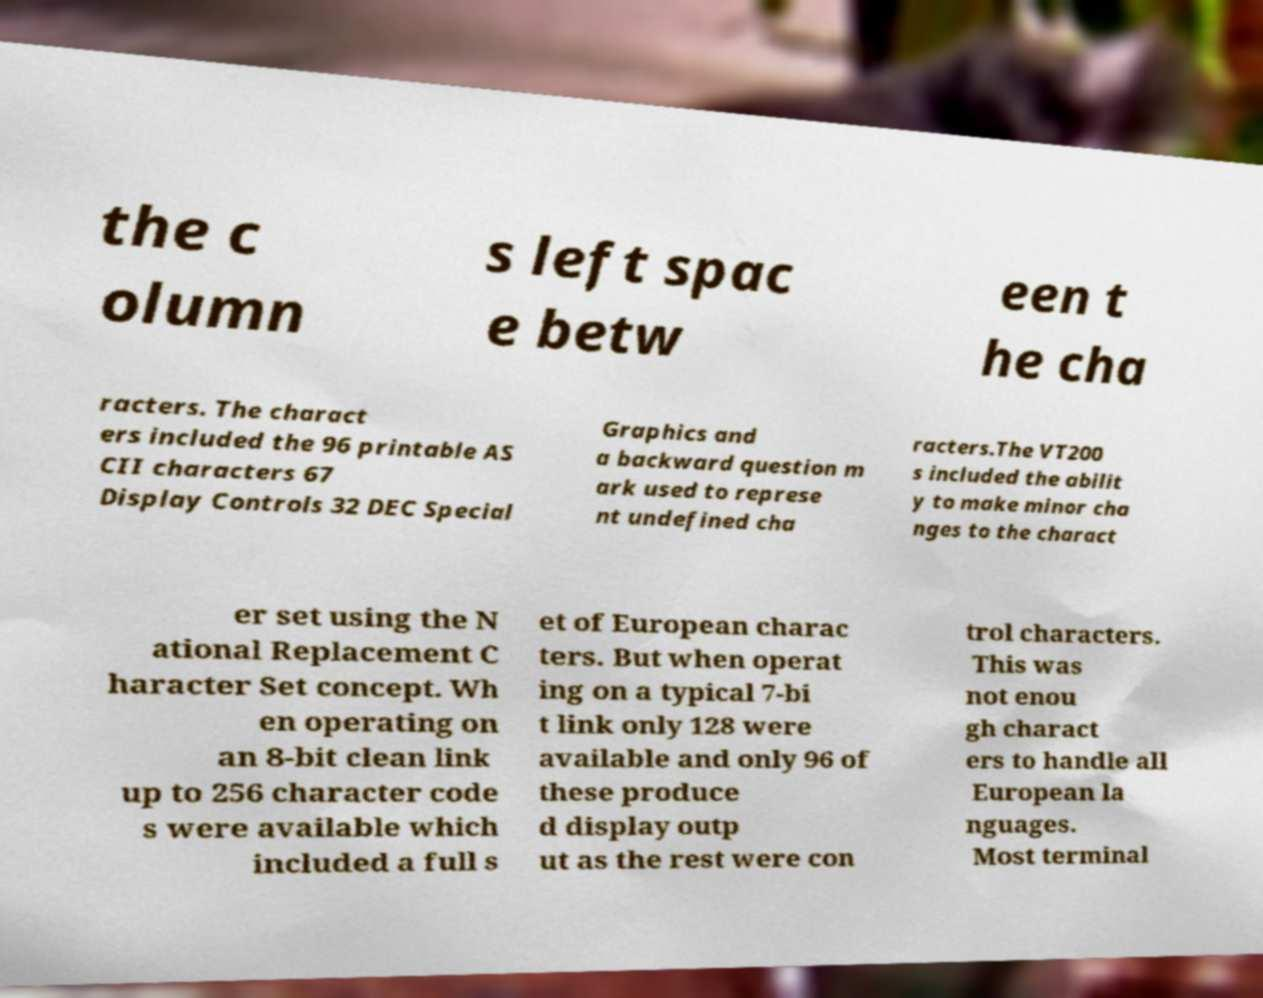Please identify and transcribe the text found in this image. the c olumn s left spac e betw een t he cha racters. The charact ers included the 96 printable AS CII characters 67 Display Controls 32 DEC Special Graphics and a backward question m ark used to represe nt undefined cha racters.The VT200 s included the abilit y to make minor cha nges to the charact er set using the N ational Replacement C haracter Set concept. Wh en operating on an 8-bit clean link up to 256 character code s were available which included a full s et of European charac ters. But when operat ing on a typical 7-bi t link only 128 were available and only 96 of these produce d display outp ut as the rest were con trol characters. This was not enou gh charact ers to handle all European la nguages. Most terminal 